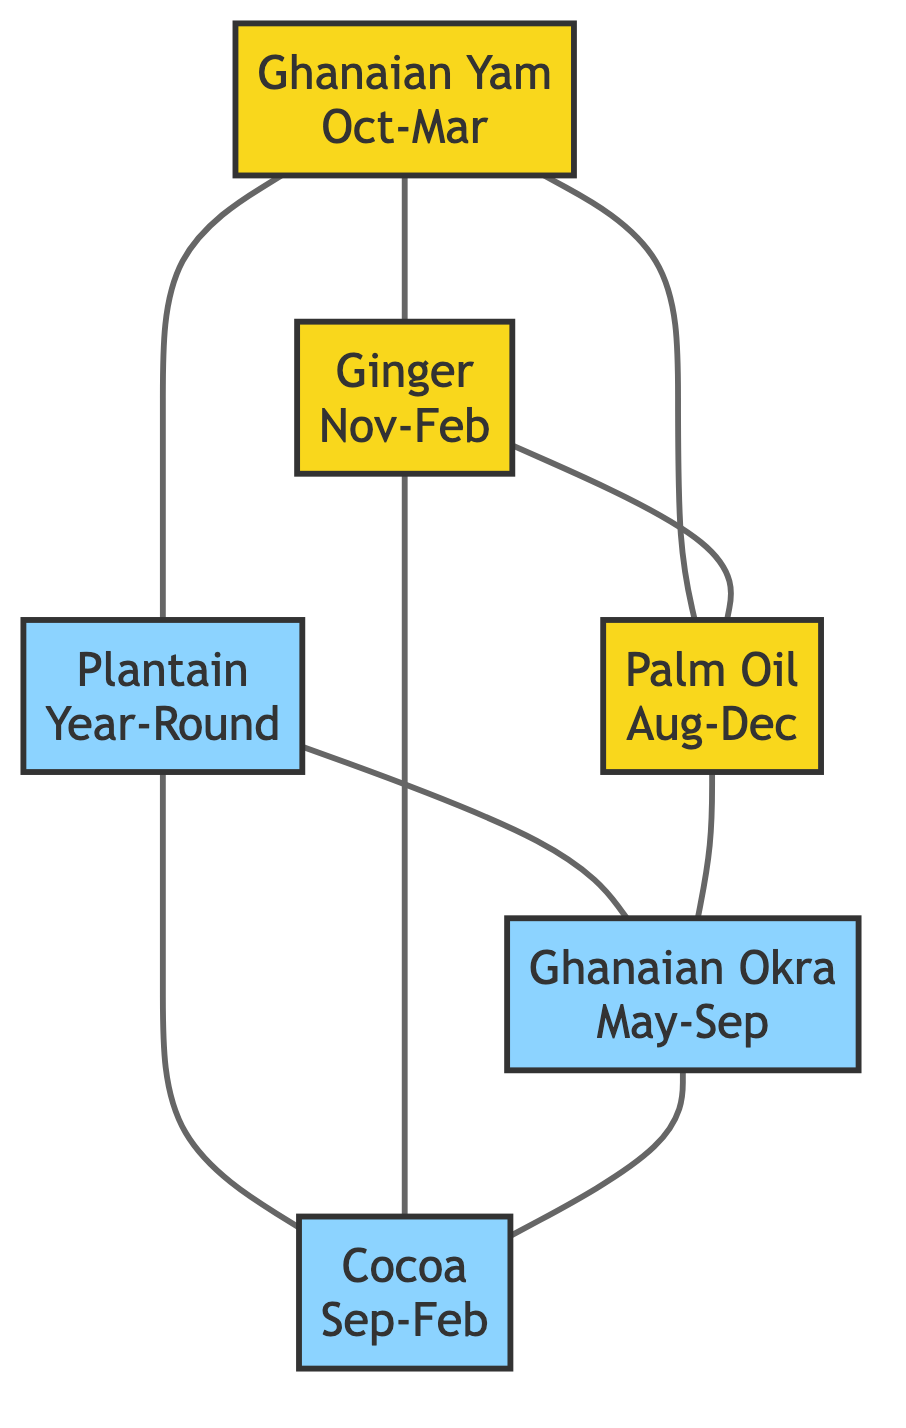What is the availability status of Ghanaian Yam? The diagram shows that Ghanaian Yam is categorized under the "High" availability status, which is represented by a yellow-colored node.
Answer: High Which produce is available year-round? The Plantain node indicates that it is available throughout the year, as it does not have seasonal limitations.
Answer: Year-Round What is the season for Ginger? In the diagram, Ginger is shown to have the season "November to February," indicating when it can be found in the market.
Answer: November to February How many nodes represent High availability? By examining the diagram, we identify three nodes labeled as high availability: Ghanaian Yam, Ginger, and Palm Oil. Therefore, there are three high availability nodes in total.
Answer: 3 Which produces are directly connected to Plantain? The diagram displays connections between Plantain and Ghanaian Okra, as well as Cocoa, indicating these as directly connected nodes.
Answer: Ghanaian Okra, Cocoa What is the relationship between Ginger and Palm Oil? The diagram illustrates a direct connection (or edge) between the nodes for Ginger and Palm Oil, indicating they are related or linked within the diagram structure.
Answer: Connected What is the seasonal range for Palm Oil? According to the diagram, Palm Oil is available from August to December, showing its specific season within the context of the graph.
Answer: August to December How many total produce items are listed? The diagram has a total of six produce items detailed within the nodes, indicating the variety of Ghanaian ingredients available in the market.
Answer: 6 Which produce has the least availability status? The nodes for Ghanaian Okra and Cocoa both indicate a "Moderate" availability status, and these are the least available according to the diagram.
Answer: Ghanaian Okra, Cocoa 